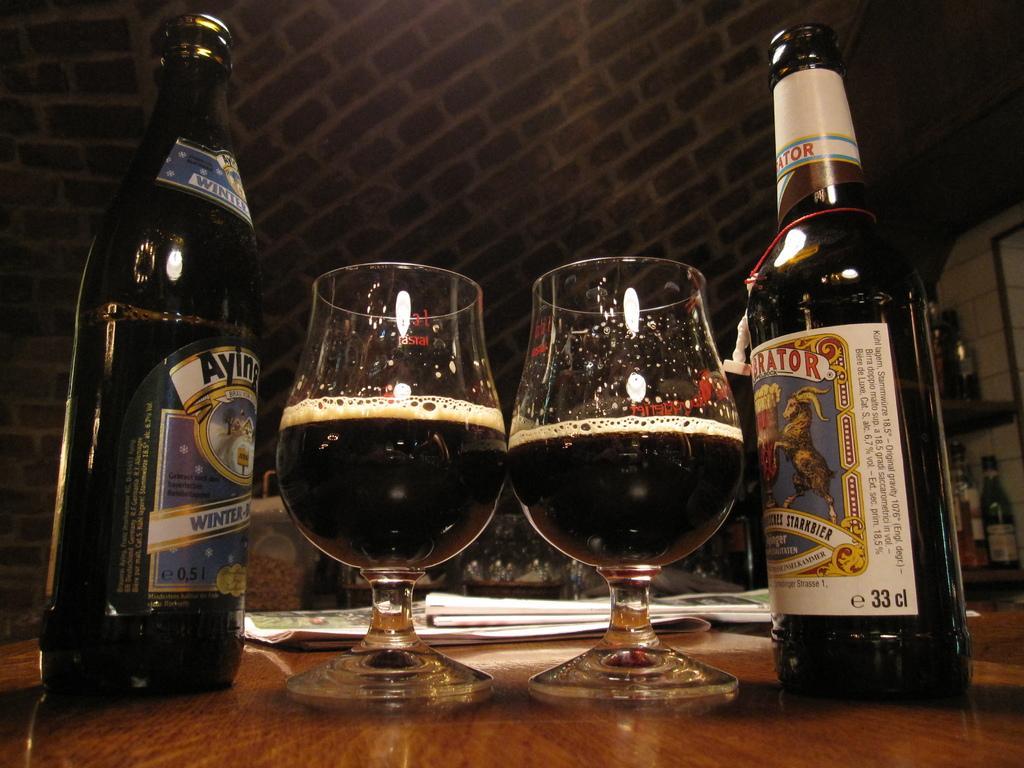Can you describe this image briefly? In this picture we can see bottles with stickers on it, glasses, papers and these all are placed on the wooden surface and in the background we can see the wall, bottles and some objects. 